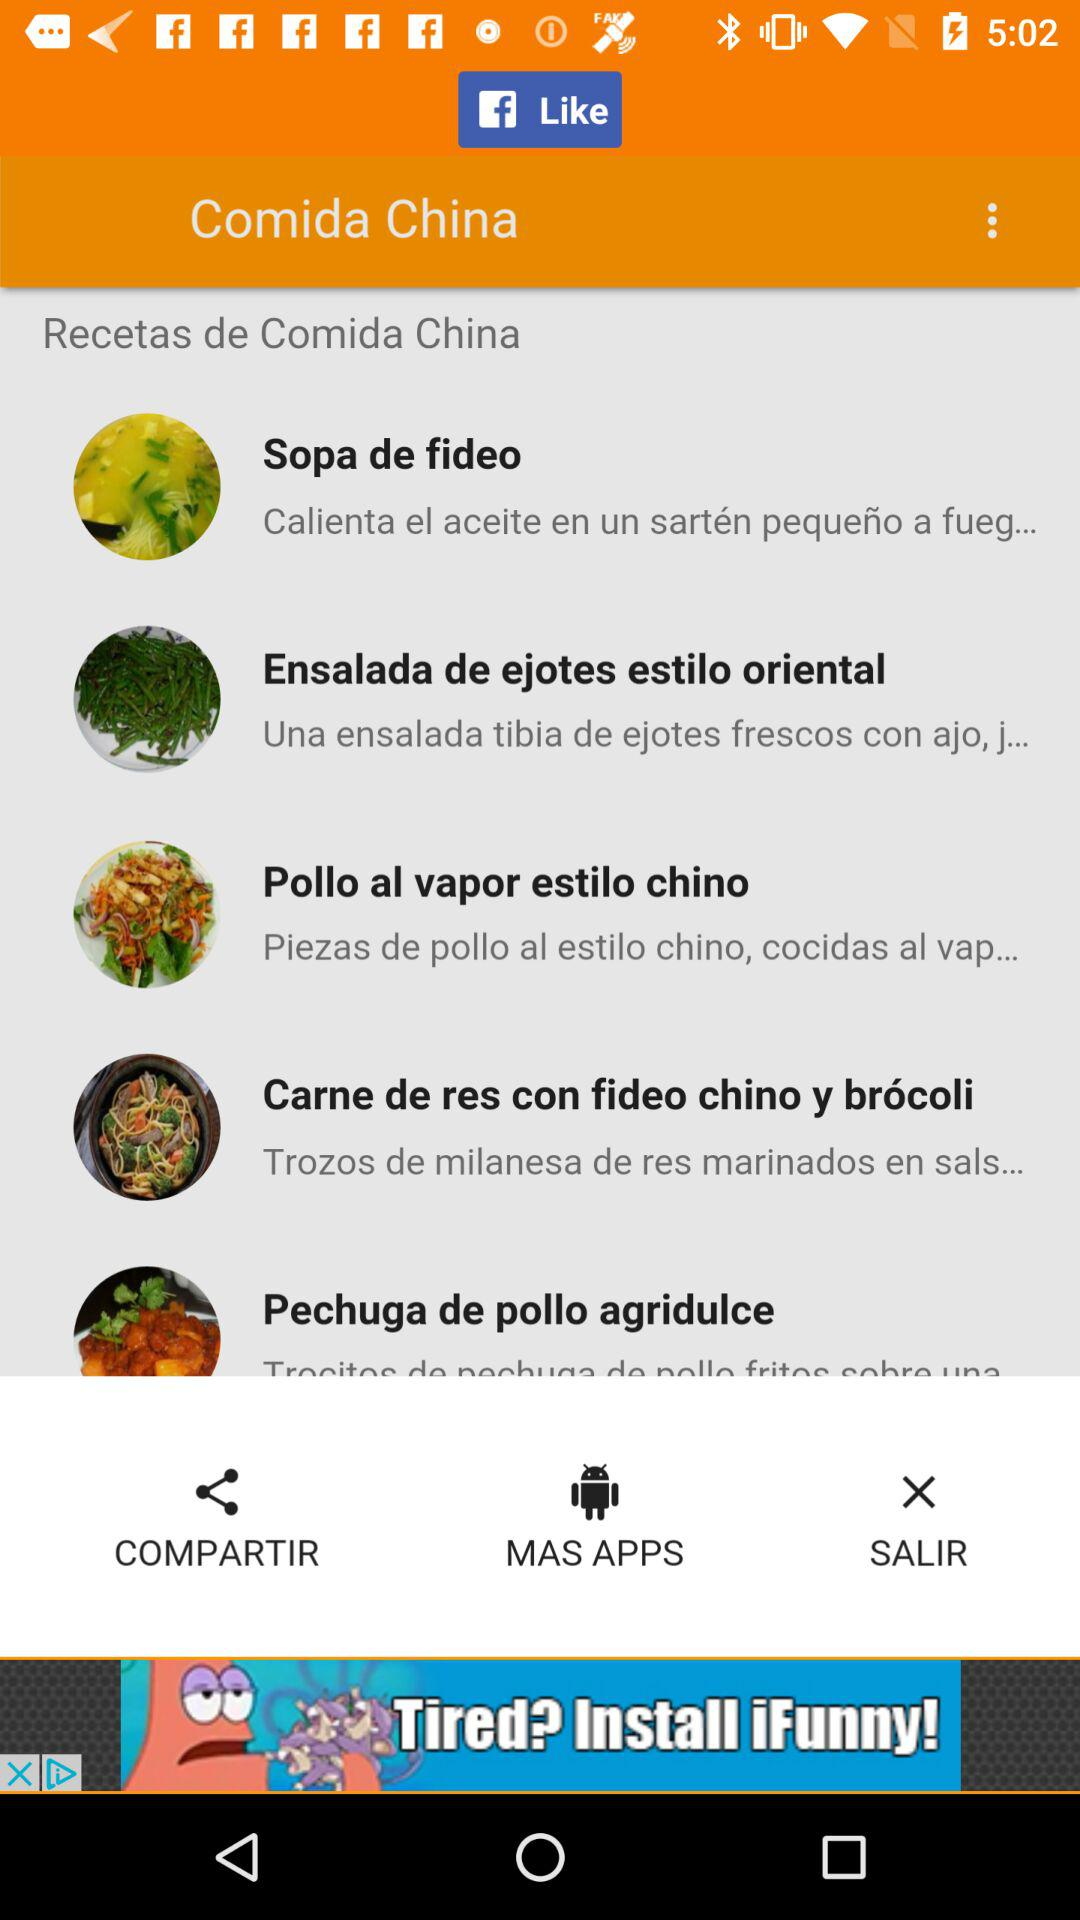How many recipes are there in total?
Answer the question using a single word or phrase. 5 